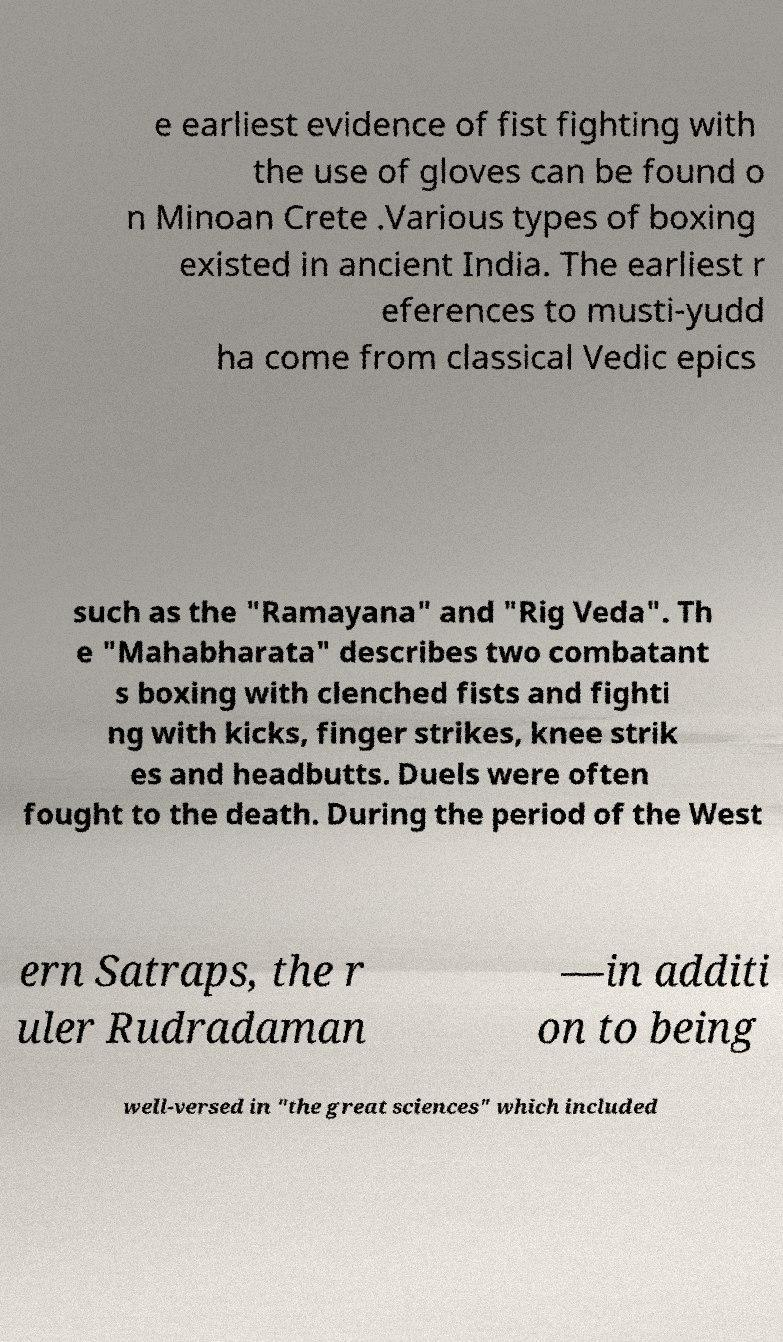Can you accurately transcribe the text from the provided image for me? e earliest evidence of fist fighting with the use of gloves can be found o n Minoan Crete .Various types of boxing existed in ancient India. The earliest r eferences to musti-yudd ha come from classical Vedic epics such as the "Ramayana" and "Rig Veda". Th e "Mahabharata" describes two combatant s boxing with clenched fists and fighti ng with kicks, finger strikes, knee strik es and headbutts. Duels were often fought to the death. During the period of the West ern Satraps, the r uler Rudradaman —in additi on to being well-versed in "the great sciences" which included 